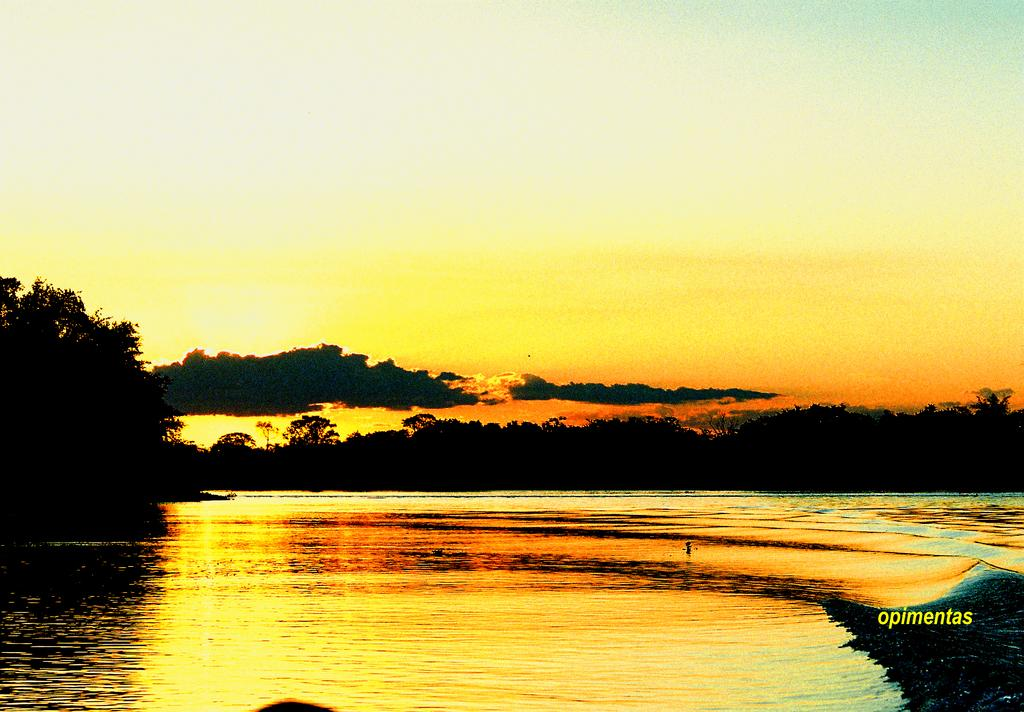What is visible in the image? Water is visible in the image. What can be seen in the background of the image? There are many trees and clouds in the background of the image. What else is visible in the background of the image? The sky is visible in the background of the image. What type of stocking is hanging from the tree in the image? There is no stocking hanging from a tree in the image. How many chickens can be seen in the image? There are no chickens present in the image. 